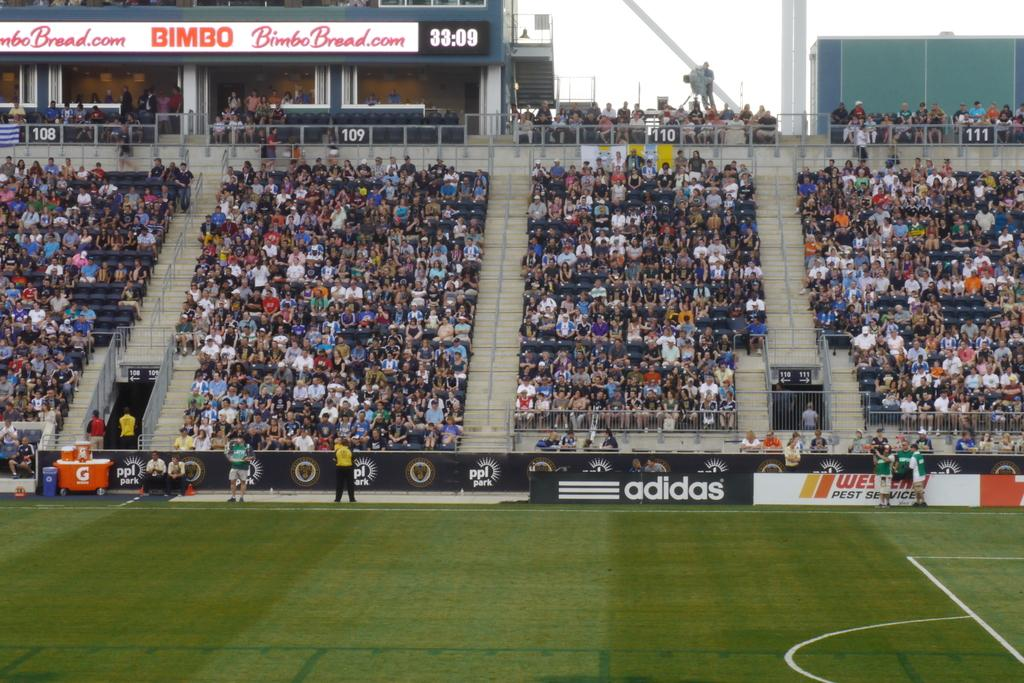<image>
Offer a succinct explanation of the picture presented. A full stadium with an ad for Bimbo Bread on it. 